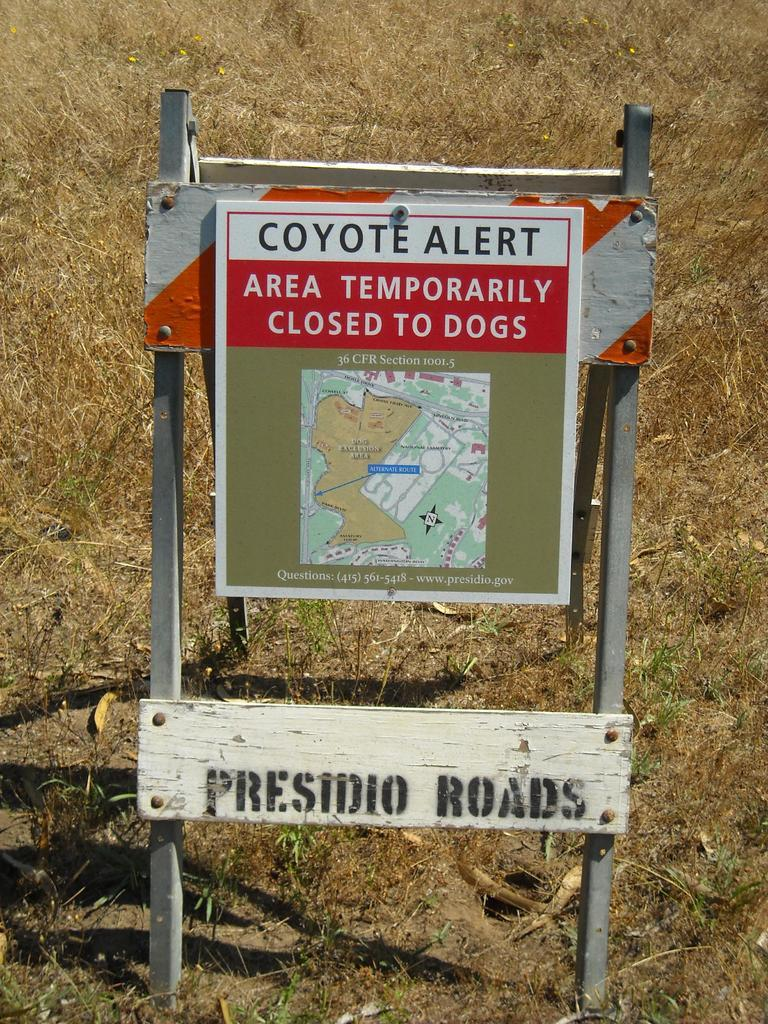What objects are present in the image that provide information or directions? There are signs boards in the image. What structure can be seen in the image that might be used for displaying or selling items? There is a stand in the image. What type of terrain is visible in the image? The land is visible in the image. What type of vegetation can be seen in the background of the image? There is dry grass in the background of the image. Where is the father sitting in the image? There is no father present in the image. What type of footwear is visible on the person in the image? There are no people or footwear visible in the image. 